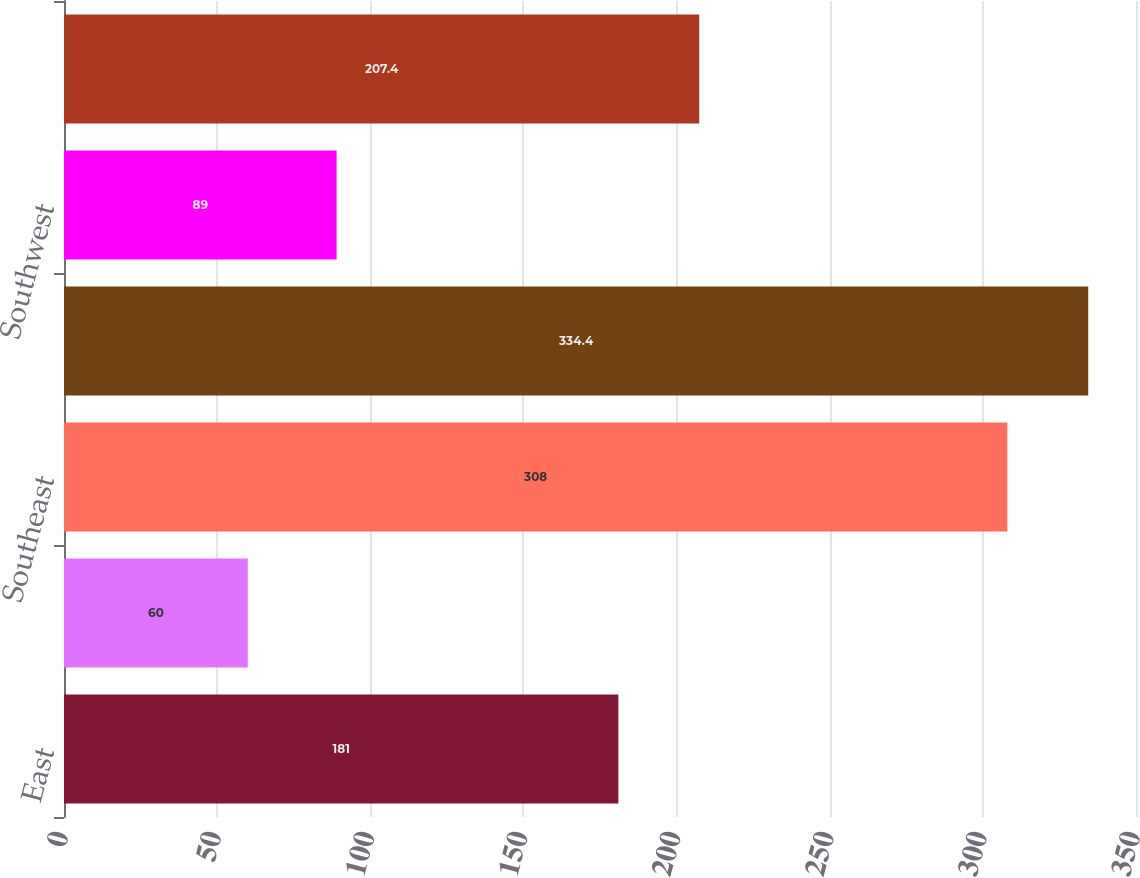Convert chart. <chart><loc_0><loc_0><loc_500><loc_500><bar_chart><fcel>East<fcel>Midwest<fcel>Southeast<fcel>South Central<fcel>Southwest<fcel>West<nl><fcel>181<fcel>60<fcel>308<fcel>334.4<fcel>89<fcel>207.4<nl></chart> 